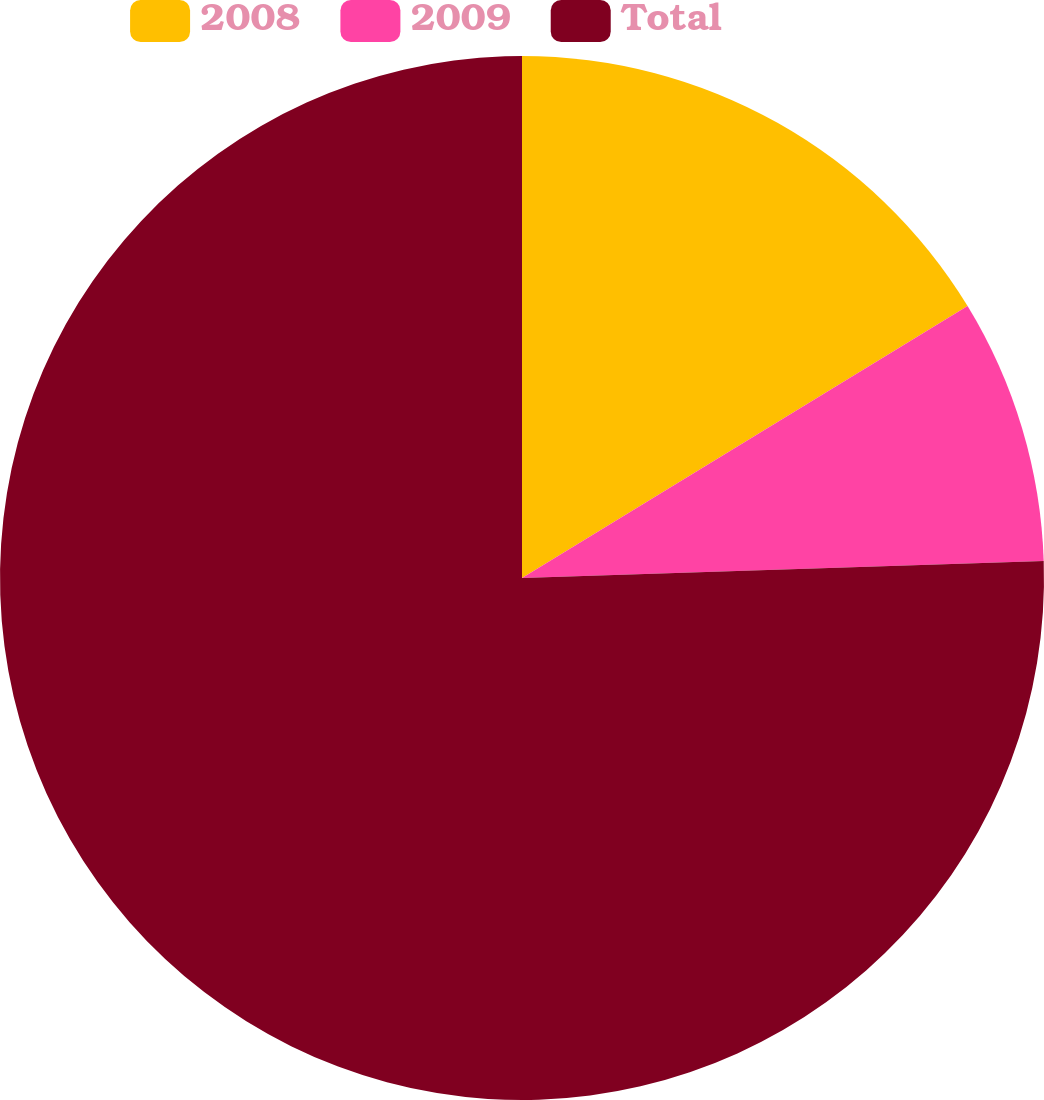<chart> <loc_0><loc_0><loc_500><loc_500><pie_chart><fcel>2008<fcel>2009<fcel>Total<nl><fcel>16.28%<fcel>8.2%<fcel>75.52%<nl></chart> 